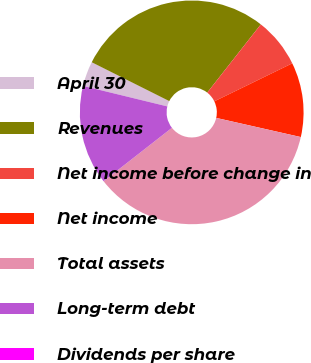Convert chart. <chart><loc_0><loc_0><loc_500><loc_500><pie_chart><fcel>April 30<fcel>Revenues<fcel>Net income before change in<fcel>Net income<fcel>Total assets<fcel>Long-term debt<fcel>Dividends per share<nl><fcel>3.59%<fcel>28.21%<fcel>7.18%<fcel>10.77%<fcel>35.9%<fcel>14.36%<fcel>0.0%<nl></chart> 